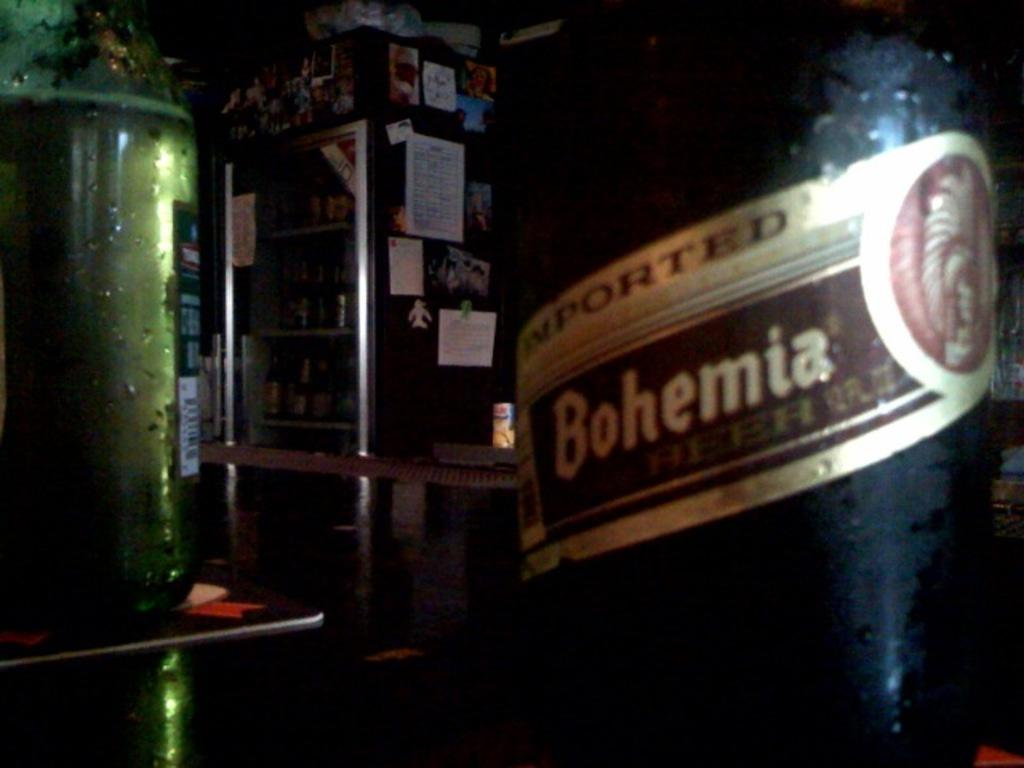<image>
Create a compact narrative representing the image presented. Dark bottle of Imported Bohemia inside a dark room. 